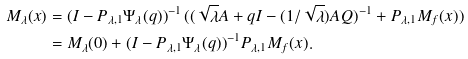<formula> <loc_0><loc_0><loc_500><loc_500>M _ { \lambda } ( x ) & = ( I - P _ { \lambda , 1 } \Psi _ { \lambda } ( q ) ) ^ { - 1 } \, ( ( \sqrt { \lambda } A + q I - ( 1 / \sqrt { \lambda } ) A Q ) ^ { - 1 } + P _ { \lambda , 1 } M _ { f } ( x ) ) \\ & = M _ { \lambda } ( 0 ) + ( I - P _ { \lambda , 1 } \Psi _ { \lambda } ( q ) ) ^ { - 1 } P _ { \lambda , 1 } M _ { f } ( x ) .</formula> 